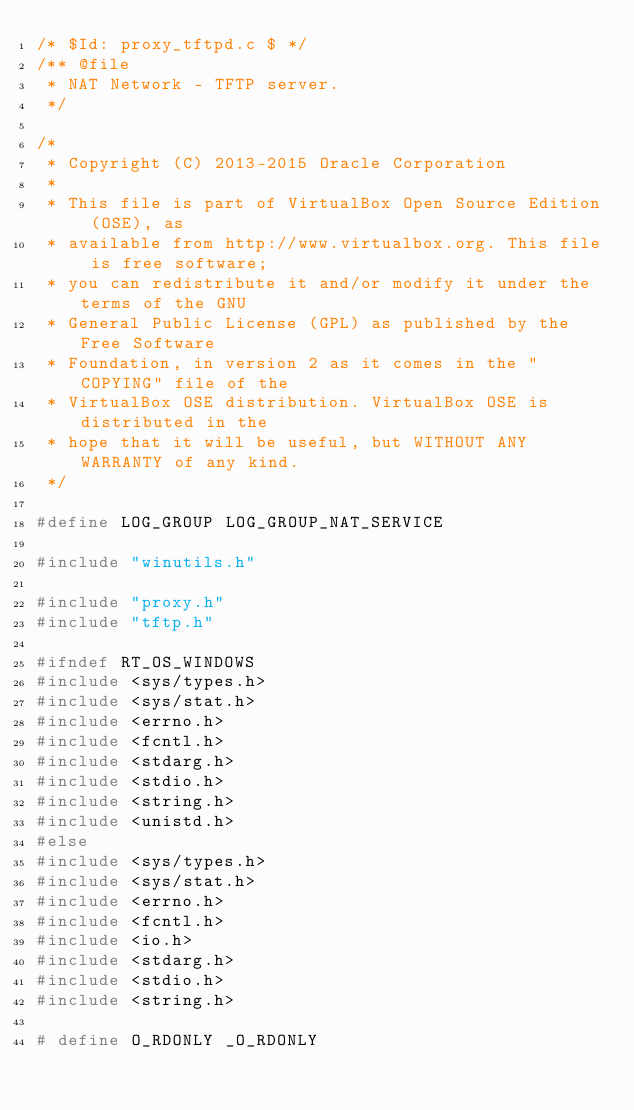Convert code to text. <code><loc_0><loc_0><loc_500><loc_500><_C_>/* $Id: proxy_tftpd.c $ */
/** @file
 * NAT Network - TFTP server.
 */

/*
 * Copyright (C) 2013-2015 Oracle Corporation
 *
 * This file is part of VirtualBox Open Source Edition (OSE), as
 * available from http://www.virtualbox.org. This file is free software;
 * you can redistribute it and/or modify it under the terms of the GNU
 * General Public License (GPL) as published by the Free Software
 * Foundation, in version 2 as it comes in the "COPYING" file of the
 * VirtualBox OSE distribution. VirtualBox OSE is distributed in the
 * hope that it will be useful, but WITHOUT ANY WARRANTY of any kind.
 */

#define LOG_GROUP LOG_GROUP_NAT_SERVICE

#include "winutils.h"

#include "proxy.h"
#include "tftp.h"

#ifndef RT_OS_WINDOWS
#include <sys/types.h>
#include <sys/stat.h>
#include <errno.h>
#include <fcntl.h>
#include <stdarg.h>
#include <stdio.h>
#include <string.h>
#include <unistd.h>
#else
#include <sys/types.h>
#include <sys/stat.h>
#include <errno.h>
#include <fcntl.h>
#include <io.h>
#include <stdarg.h>
#include <stdio.h>
#include <string.h>

# define O_RDONLY _O_RDONLY</code> 